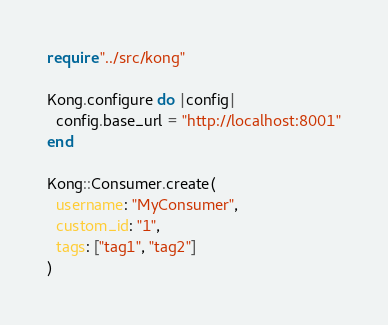Convert code to text. <code><loc_0><loc_0><loc_500><loc_500><_Crystal_>require "../src/kong"

Kong.configure do |config|
  config.base_url = "http://localhost:8001"
end

Kong::Consumer.create(
  username: "MyConsumer",
  custom_id: "1",
  tags: ["tag1", "tag2"]
)
</code> 